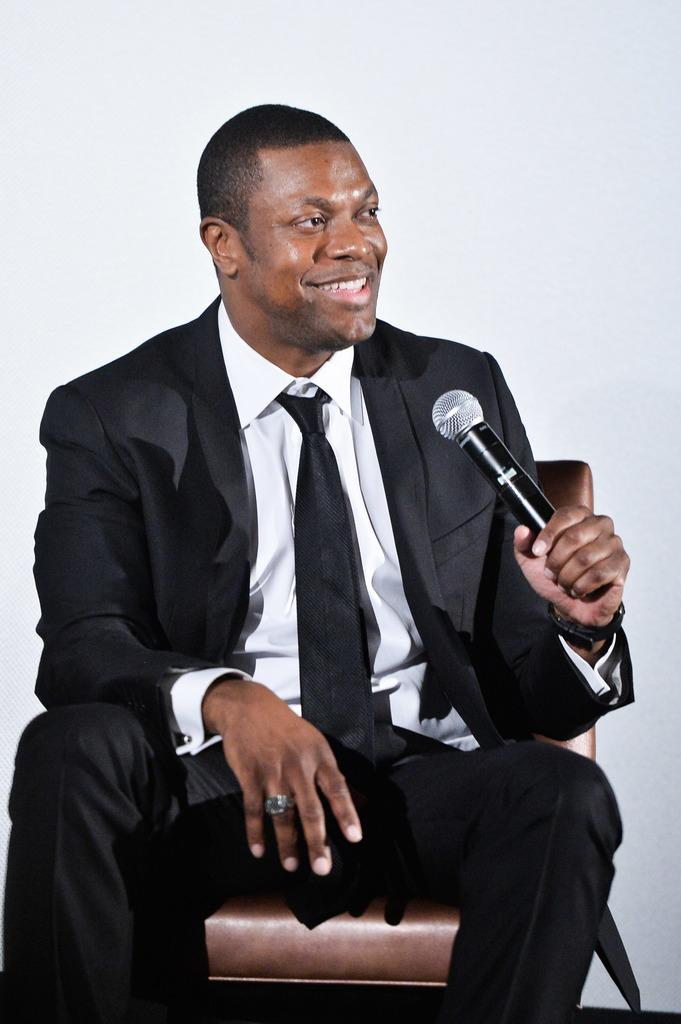Who is the main subject in the image? There is a man in the image. What is the man wearing? The man is wearing a black suit. What is the man holding in the image? The man is holding a mic. What is the man's posture in the image? The man is sitting on a chair. What is the man's facial expression in the image? The man is smiling. What type of liquid is the man regretting in the image? There is no liquid or regret present in the image; the man is smiling while holding a mic and sitting on a chair. 